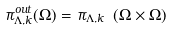<formula> <loc_0><loc_0><loc_500><loc_500>\pi _ { \Lambda , k } ^ { o u t } ( \Omega ) = \pi _ { \Lambda , k } \ ( \Omega \times \Omega )</formula> 